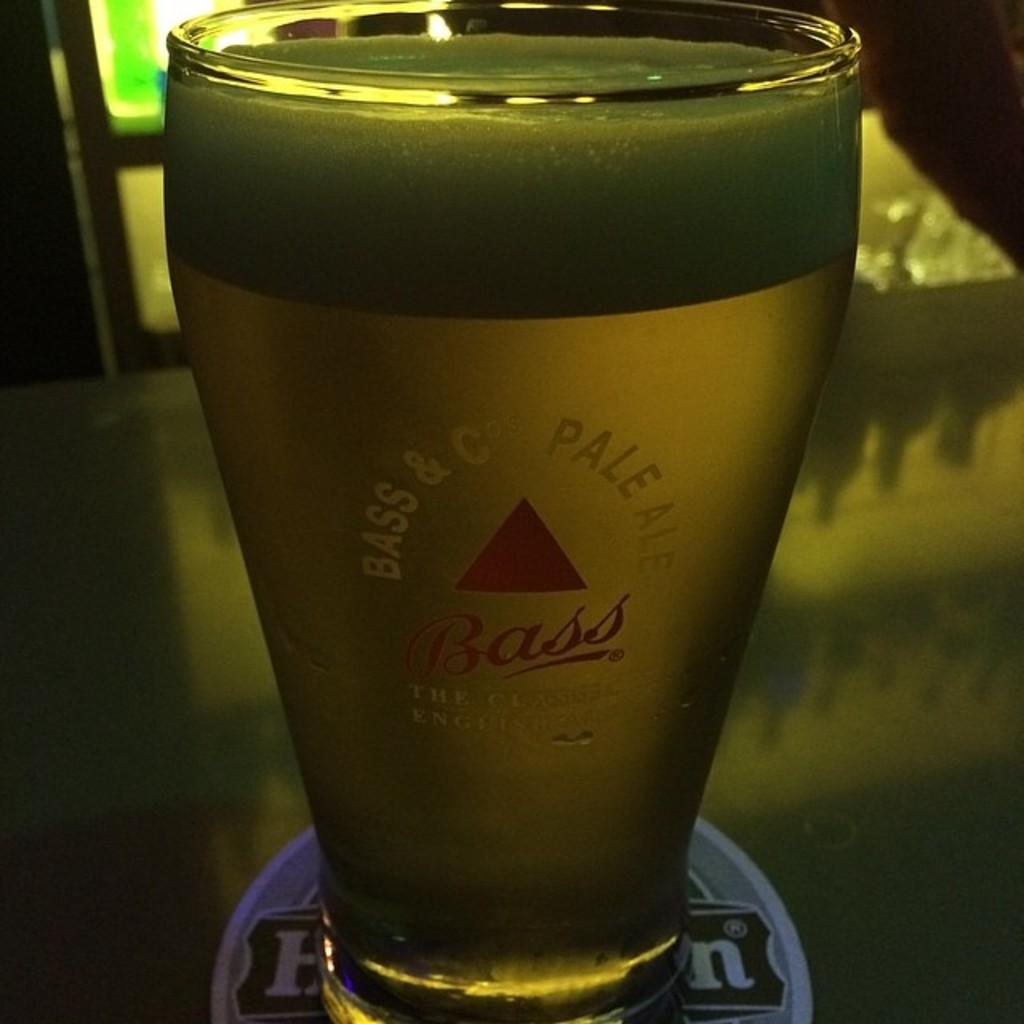Provide a one-sentence caption for the provided image. A glass of Bass pale ale sits on a round coaster on a bar. 